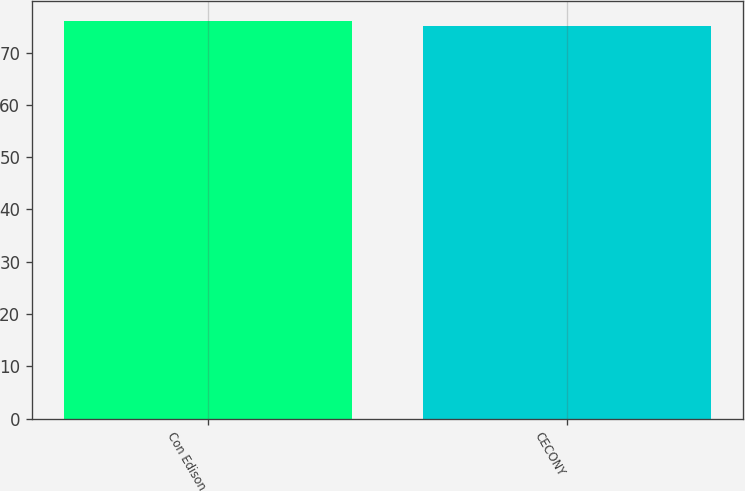<chart> <loc_0><loc_0><loc_500><loc_500><bar_chart><fcel>Con Edison<fcel>CECONY<nl><fcel>76<fcel>75<nl></chart> 